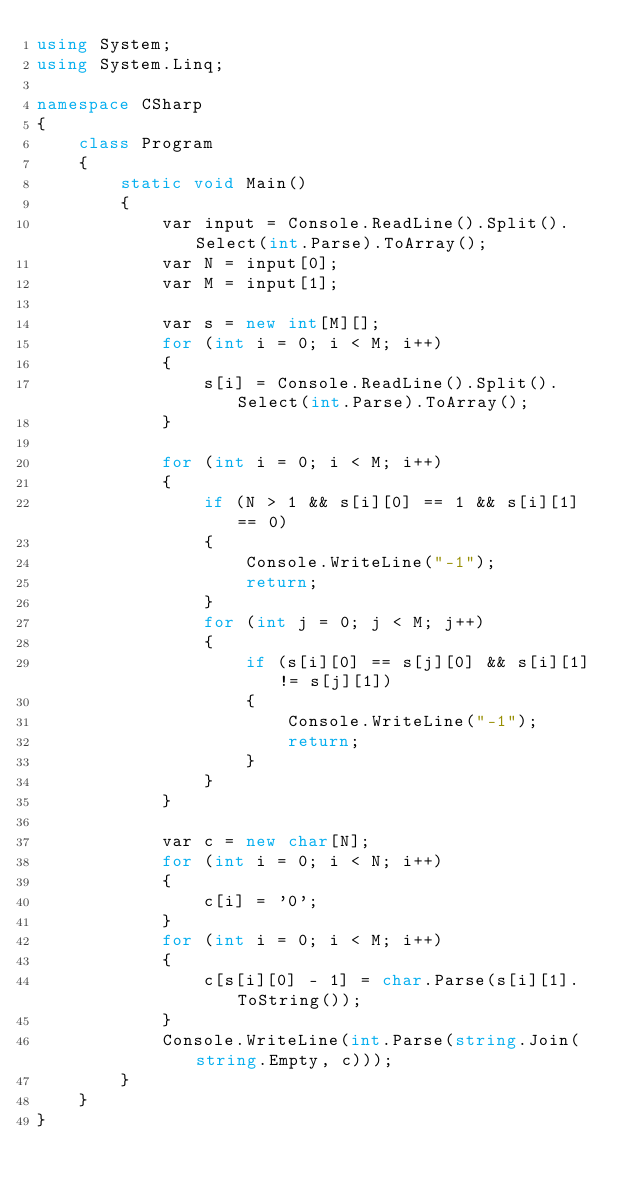<code> <loc_0><loc_0><loc_500><loc_500><_C#_>using System;
using System.Linq;

namespace CSharp
{
    class Program
    {
        static void Main()
        {
            var input = Console.ReadLine().Split().Select(int.Parse).ToArray();
            var N = input[0];
            var M = input[1];

            var s = new int[M][];
            for (int i = 0; i < M; i++)
            {
                s[i] = Console.ReadLine().Split().Select(int.Parse).ToArray();
            }

            for (int i = 0; i < M; i++)
            {
                if (N > 1 && s[i][0] == 1 && s[i][1] == 0)
                {
                    Console.WriteLine("-1");
                    return;
                }
                for (int j = 0; j < M; j++)
                {
                    if (s[i][0] == s[j][0] && s[i][1] != s[j][1])
                    {
                        Console.WriteLine("-1");
                        return;
                    }
                }
            }

            var c = new char[N];
            for (int i = 0; i < N; i++)
            {
                c[i] = '0';
            }
            for (int i = 0; i < M; i++)
            {
                c[s[i][0] - 1] = char.Parse(s[i][1].ToString());
            }
            Console.WriteLine(int.Parse(string.Join(string.Empty, c)));
        }
    }
}</code> 